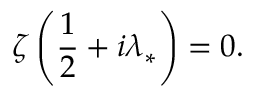Convert formula to latex. <formula><loc_0><loc_0><loc_500><loc_500>\zeta \left ( \frac { 1 } { 2 } + i \lambda _ { * } \right ) = 0 .</formula> 